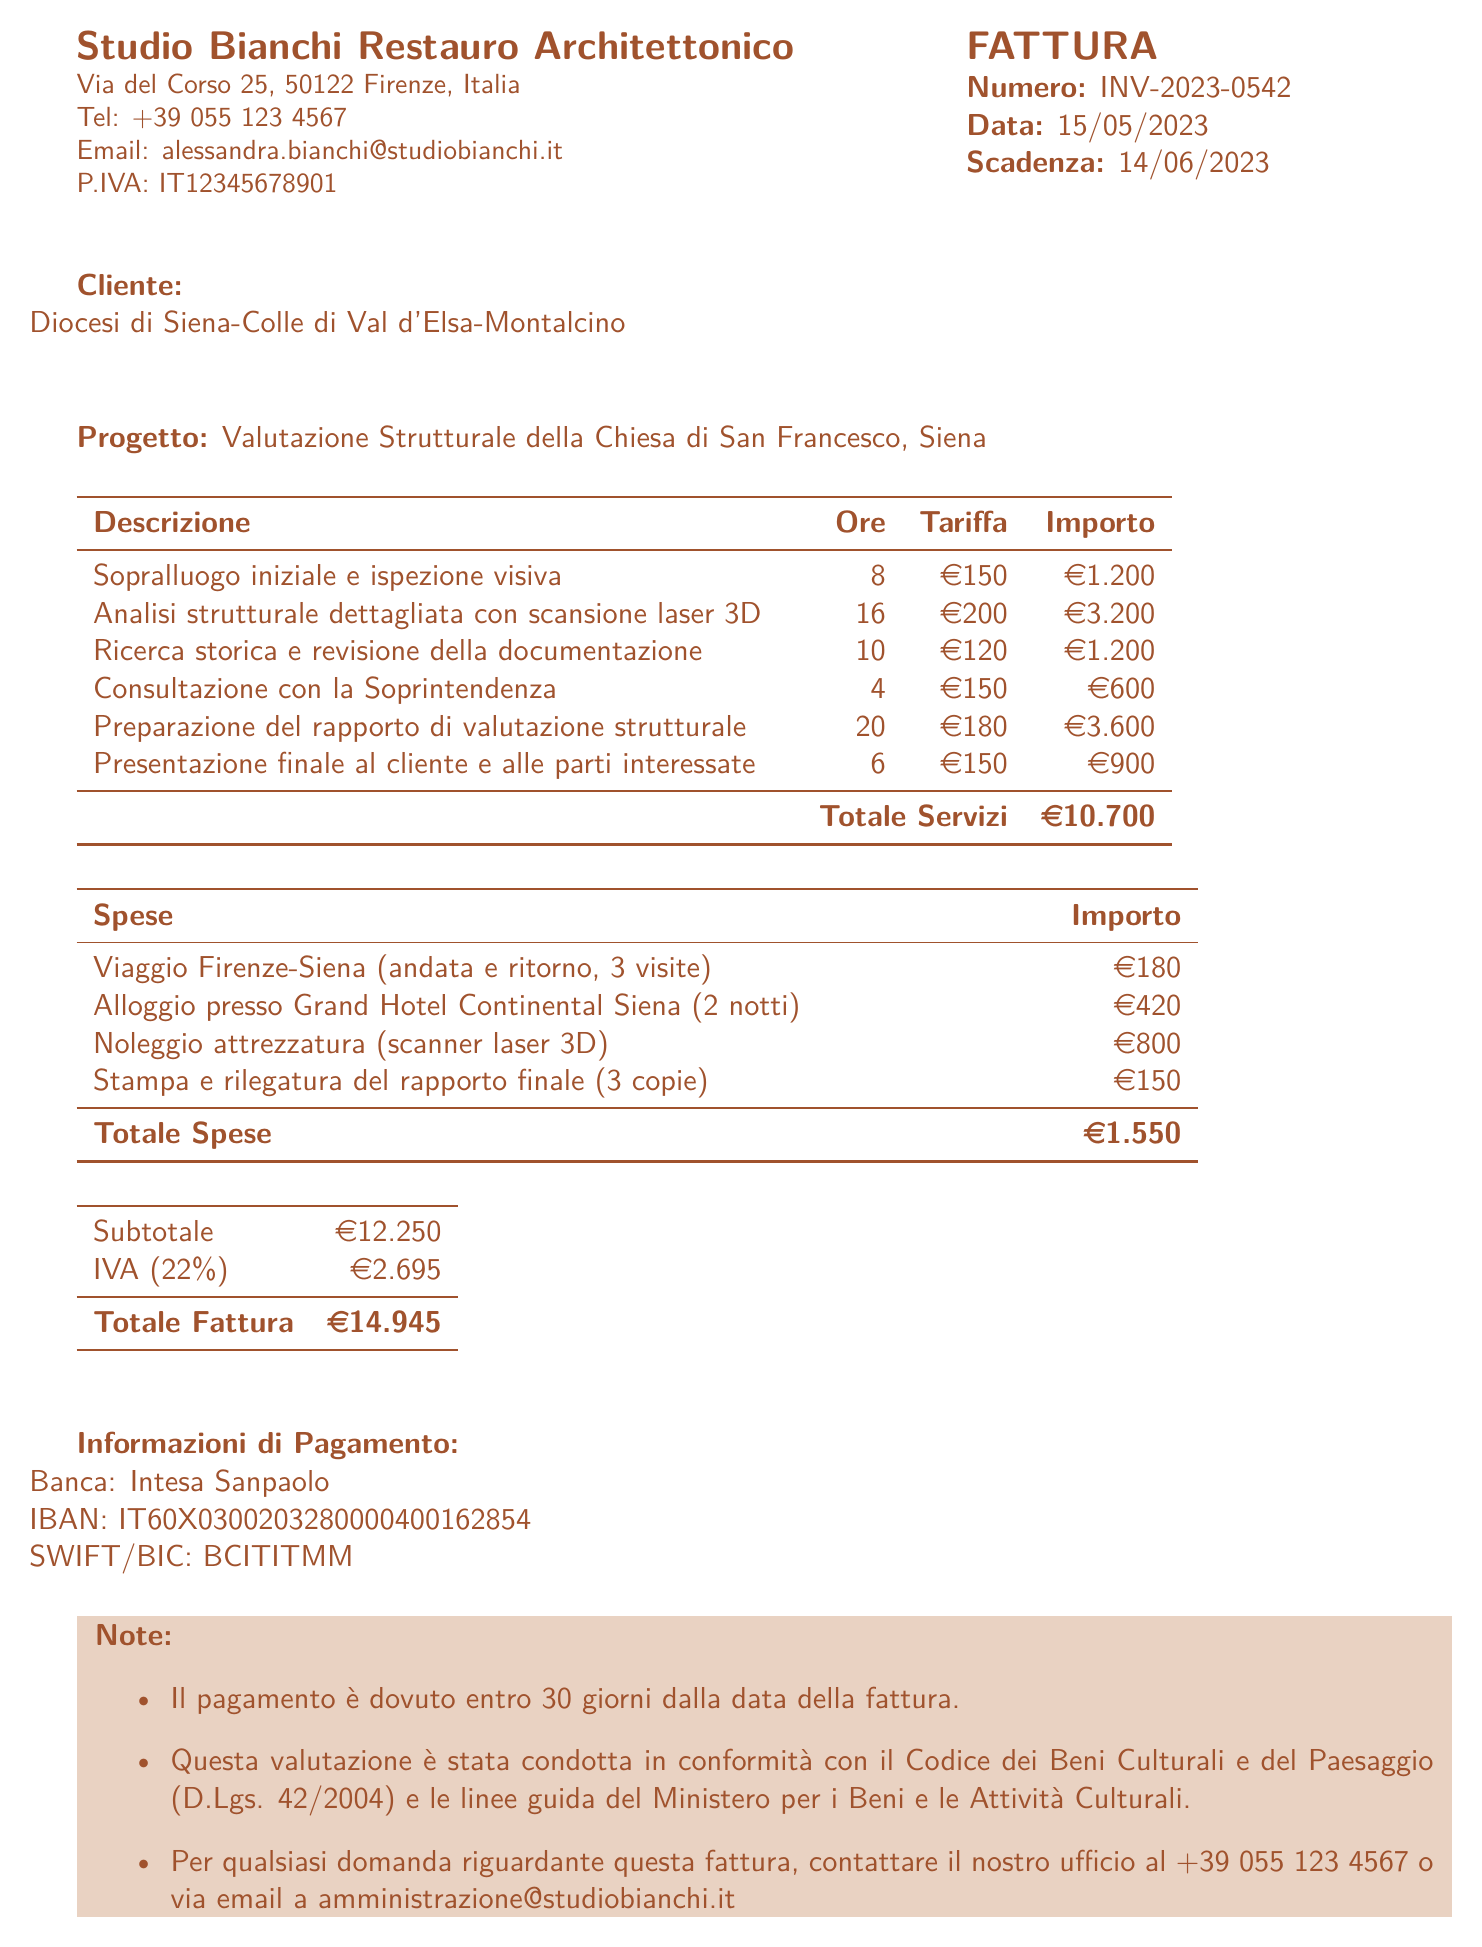what is the invoice number? The invoice number is prominently displayed at the top of the document as a key identifier.
Answer: INV-2023-0542 when is the payment due? The payment due date is specified to ensure timely settlement of the invoice.
Answer: 14/06/2023 who is the client? The client's name is prominently mentioned in the invoice, indicating the party receiving the services.
Answer: Diocesi di Siena-Colle di Val d'Elsa-Montalcino what is the total amount due? The total amount due at the bottom of the invoice summarizes all services and expenses.
Answer: € 14.945 how many hours were spent on the detailed structural analysis? The hours allocated for each service are itemized in the document for clarity.
Answer: 16 what is the rate for the initial site visit? The document specifies rates for different services, which includes a detailed list.
Answer: € 150 what are the total expenses? The total expenses detail all associated costs, which culminates in the expenses section.
Answer: € 1.550 how many copies of the final report were printed? The number of printed copies is mentioned under the expenses to provide transparency of costs.
Answer: 3 who prepared the structural assessment report? The architect's name is provided on the invoice, indicating the responsible party for the services rendered.
Answer: Dr. Alessandra Bianchi 